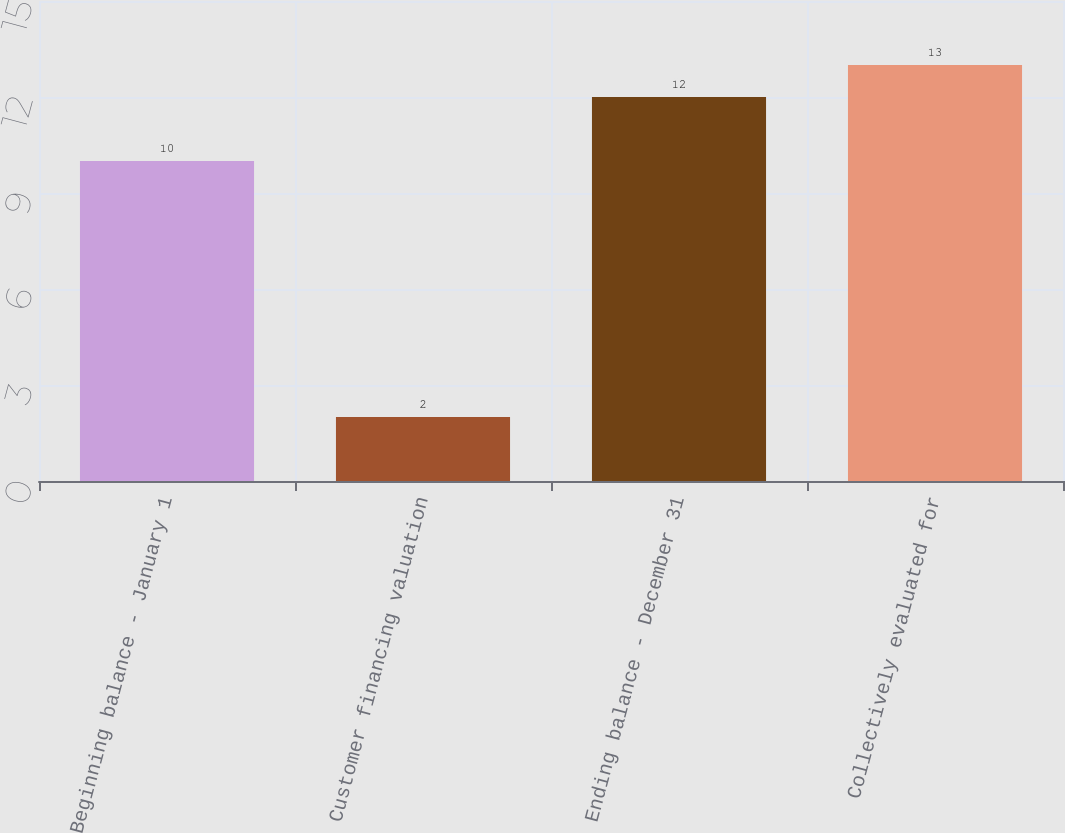Convert chart. <chart><loc_0><loc_0><loc_500><loc_500><bar_chart><fcel>Beginning balance - January 1<fcel>Customer financing valuation<fcel>Ending balance - December 31<fcel>Collectively evaluated for<nl><fcel>10<fcel>2<fcel>12<fcel>13<nl></chart> 